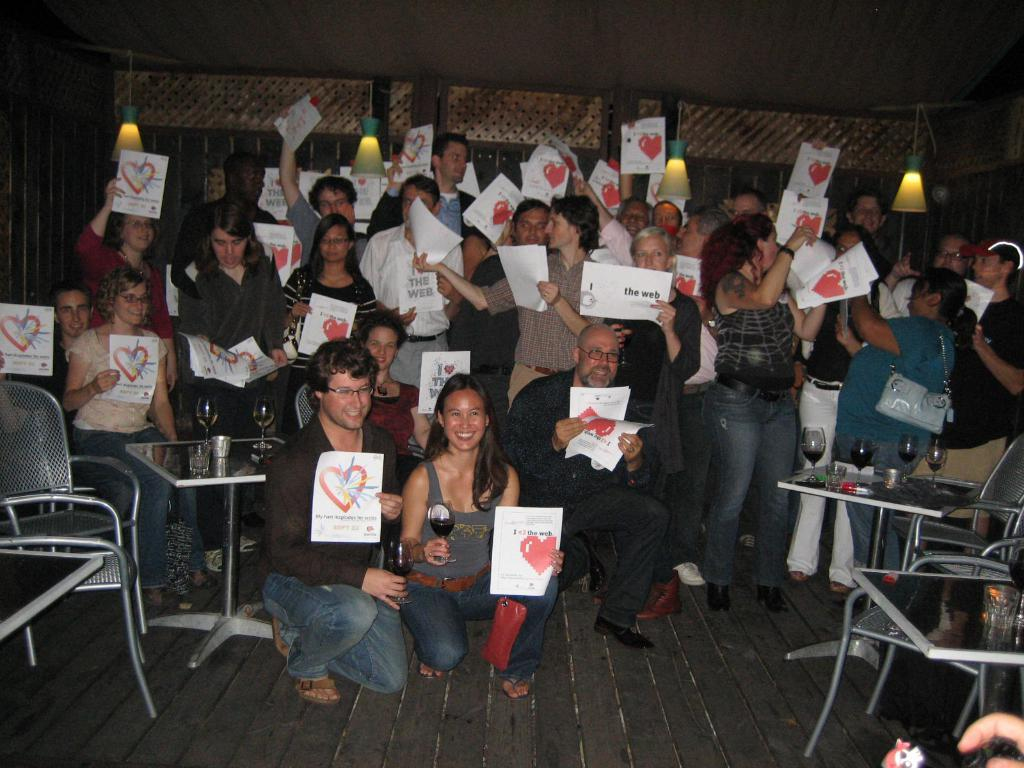What can be seen in the image involving people? There are persons standing in the image. What type of furniture is present in the image? There are chairs and tables in the image. What objects are on the tables? There are glasses on the tables. What part of the room can be seen in the image? The floor is visible in the image. What type of illumination is present in the image? There are lights in the image. What is the average income of the persons in the image? There is no information about the income of the persons in the image, as it is not relevant to the visual content. 